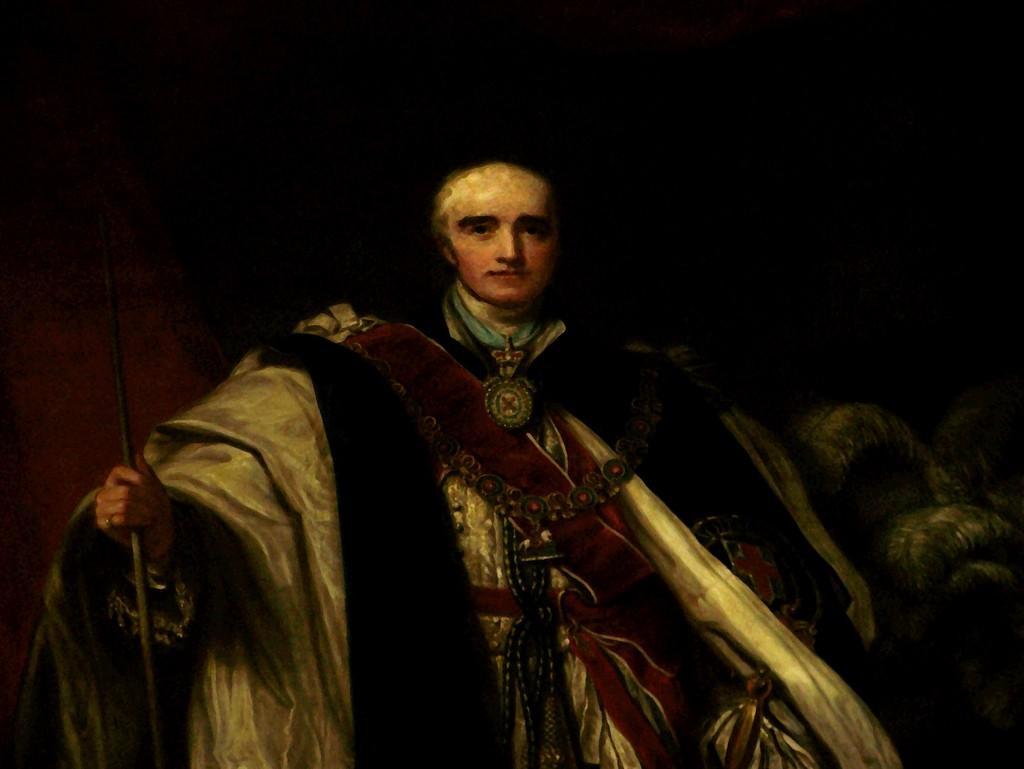Please provide a concise description of this image. This is a painting and here we can see a person wearing costume and holding a stick. 